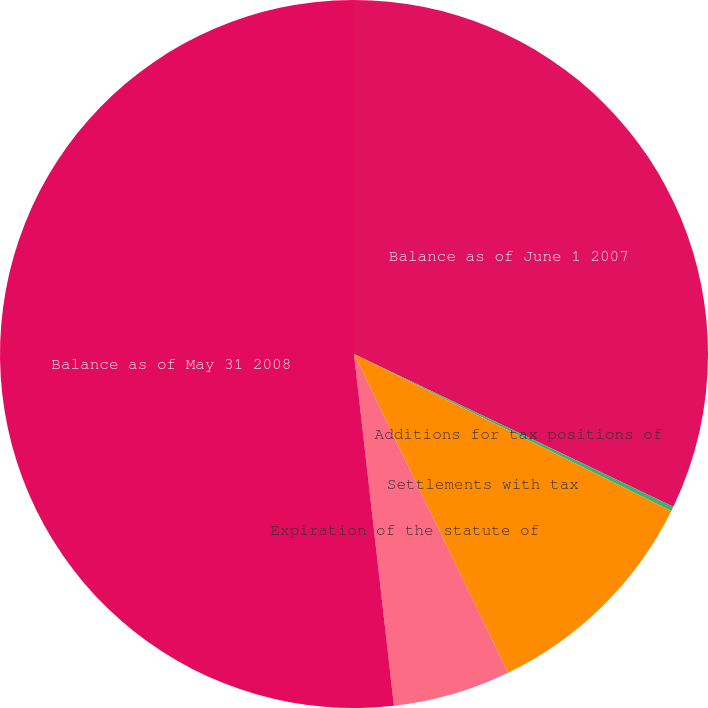Convert chart. <chart><loc_0><loc_0><loc_500><loc_500><pie_chart><fcel>Balance as of June 1 2007<fcel>Additions for tax positions of<fcel>Settlements with tax<fcel>Expiration of the statute of<fcel>Balance as of May 31 2008<nl><fcel>32.1%<fcel>0.21%<fcel>10.52%<fcel>5.37%<fcel>51.8%<nl></chart> 